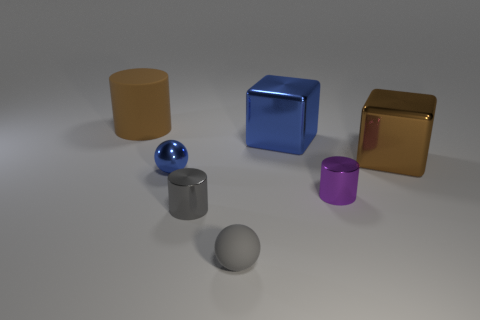Which objects in the image are reflective, and how can you tell? The objects with reflective properties in this image are the bright blue sphere, and the shiny gold cube. You can tell because they have visible highlights and reflections on their surfaces that mirror the environment, which indicates that they are reflective. 